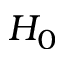Convert formula to latex. <formula><loc_0><loc_0><loc_500><loc_500>H _ { 0 }</formula> 